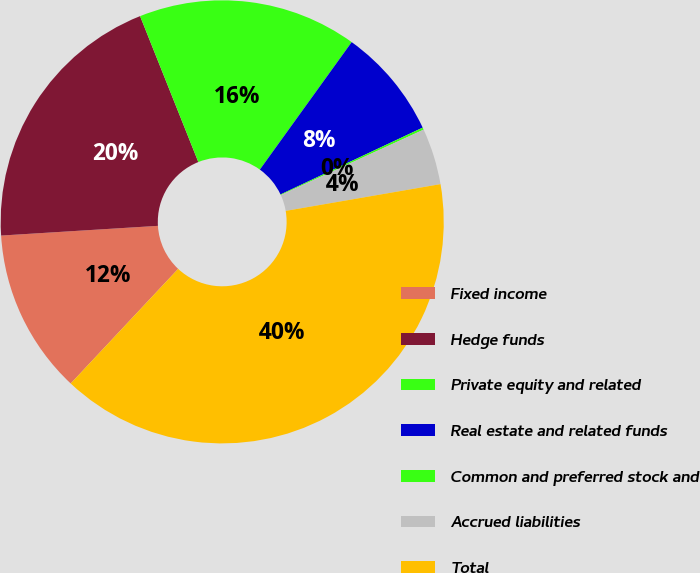Convert chart to OTSL. <chart><loc_0><loc_0><loc_500><loc_500><pie_chart><fcel>Fixed income<fcel>Hedge funds<fcel>Private equity and related<fcel>Real estate and related funds<fcel>Common and preferred stock and<fcel>Accrued liabilities<fcel>Total<nl><fcel>12.03%<fcel>19.94%<fcel>15.98%<fcel>8.07%<fcel>0.16%<fcel>4.11%<fcel>39.71%<nl></chart> 